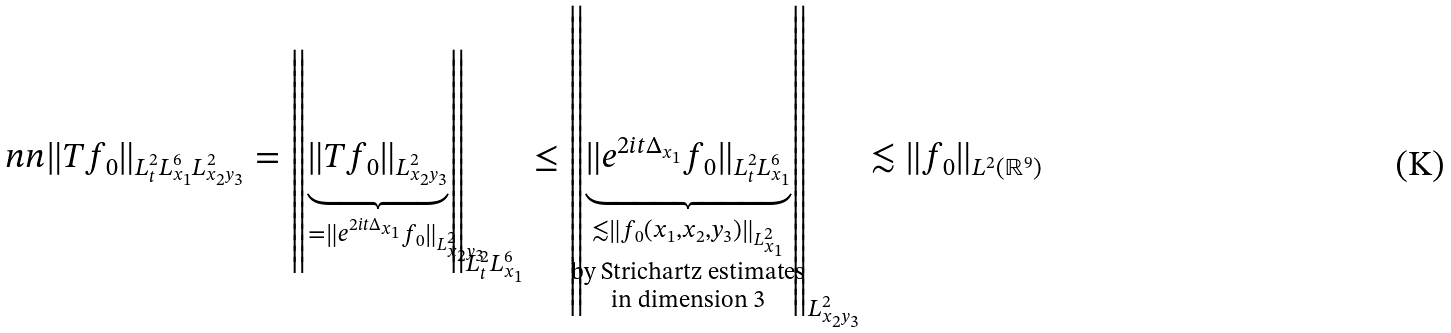Convert formula to latex. <formula><loc_0><loc_0><loc_500><loc_500>& \ n n \| T f _ { 0 } \| _ { L ^ { 2 } _ { t } L ^ { 6 } _ { x _ { 1 } } L ^ { 2 } _ { x _ { 2 } y _ { 3 } } } = \left \| \underbrace { \| T f _ { 0 } \| _ { L ^ { 2 } _ { x _ { 2 } y _ { 3 } } } } _ { \mathclap { \quad \, = \| e ^ { 2 i t \Delta _ { x _ { 1 } } } f _ { 0 } \| _ { L ^ { 2 } _ { x _ { 2 } y _ { 3 } } } } } \right \| _ { L ^ { 2 } _ { t } L ^ { 6 } _ { x _ { 1 } } } \leq \left \| \underbrace { \| e ^ { 2 i t \Delta _ { x _ { 1 } } } f _ { 0 } \| _ { L ^ { 2 } _ { t } L ^ { 6 } _ { x _ { 1 } } } } _ { \mathclap { \substack { \lesssim \| f _ { 0 } ( x _ { 1 } , x _ { 2 } , y _ { 3 } ) \| _ { L ^ { 2 } _ { x _ { 1 } } } \\ \text {by Strichartz estimates} \\ \text {in dimension 3} } } } \right \| _ { L ^ { 2 } _ { x _ { 2 } y _ { 3 } } } \lesssim \| f _ { 0 } \| _ { L ^ { 2 } ( \mathbb { R } ^ { 9 } ) }</formula> 